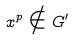<formula> <loc_0><loc_0><loc_500><loc_500>x ^ { p } \notin G ^ { \prime }</formula> 